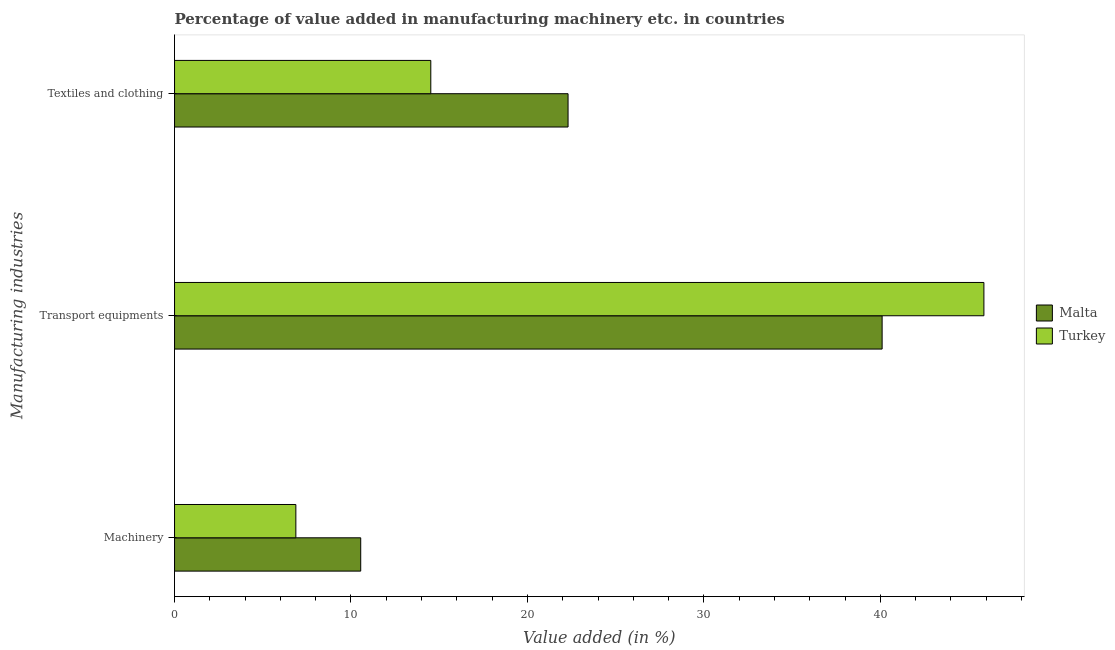Are the number of bars on each tick of the Y-axis equal?
Ensure brevity in your answer.  Yes. How many bars are there on the 3rd tick from the bottom?
Your answer should be compact. 2. What is the label of the 3rd group of bars from the top?
Ensure brevity in your answer.  Machinery. What is the value added in manufacturing machinery in Turkey?
Provide a short and direct response. 6.88. Across all countries, what is the maximum value added in manufacturing textile and clothing?
Your answer should be very brief. 22.3. Across all countries, what is the minimum value added in manufacturing textile and clothing?
Keep it short and to the point. 14.52. In which country was the value added in manufacturing textile and clothing maximum?
Provide a short and direct response. Malta. What is the total value added in manufacturing machinery in the graph?
Give a very brief answer. 17.43. What is the difference between the value added in manufacturing textile and clothing in Turkey and that in Malta?
Keep it short and to the point. -7.78. What is the difference between the value added in manufacturing machinery in Malta and the value added in manufacturing textile and clothing in Turkey?
Your answer should be compact. -3.97. What is the average value added in manufacturing machinery per country?
Provide a succinct answer. 8.71. What is the difference between the value added in manufacturing transport equipments and value added in manufacturing textile and clothing in Malta?
Make the answer very short. 17.8. In how many countries, is the value added in manufacturing transport equipments greater than 20 %?
Keep it short and to the point. 2. What is the ratio of the value added in manufacturing machinery in Turkey to that in Malta?
Make the answer very short. 0.65. Is the value added in manufacturing textile and clothing in Turkey less than that in Malta?
Your response must be concise. Yes. What is the difference between the highest and the second highest value added in manufacturing machinery?
Provide a succinct answer. 3.68. What is the difference between the highest and the lowest value added in manufacturing machinery?
Your answer should be compact. 3.68. In how many countries, is the value added in manufacturing transport equipments greater than the average value added in manufacturing transport equipments taken over all countries?
Give a very brief answer. 1. Is the sum of the value added in manufacturing textile and clothing in Turkey and Malta greater than the maximum value added in manufacturing transport equipments across all countries?
Provide a succinct answer. No. What does the 1st bar from the bottom in Textiles and clothing represents?
Make the answer very short. Malta. Is it the case that in every country, the sum of the value added in manufacturing machinery and value added in manufacturing transport equipments is greater than the value added in manufacturing textile and clothing?
Your answer should be compact. Yes. How many bars are there?
Ensure brevity in your answer.  6. Are all the bars in the graph horizontal?
Make the answer very short. Yes. How many countries are there in the graph?
Keep it short and to the point. 2. What is the difference between two consecutive major ticks on the X-axis?
Your response must be concise. 10. Does the graph contain any zero values?
Offer a very short reply. No. Does the graph contain grids?
Give a very brief answer. No. How are the legend labels stacked?
Your response must be concise. Vertical. What is the title of the graph?
Offer a very short reply. Percentage of value added in manufacturing machinery etc. in countries. What is the label or title of the X-axis?
Give a very brief answer. Value added (in %). What is the label or title of the Y-axis?
Your response must be concise. Manufacturing industries. What is the Value added (in %) of Malta in Machinery?
Offer a terse response. 10.55. What is the Value added (in %) in Turkey in Machinery?
Ensure brevity in your answer.  6.88. What is the Value added (in %) of Malta in Transport equipments?
Provide a short and direct response. 40.1. What is the Value added (in %) in Turkey in Transport equipments?
Offer a very short reply. 45.87. What is the Value added (in %) in Malta in Textiles and clothing?
Your answer should be compact. 22.3. What is the Value added (in %) of Turkey in Textiles and clothing?
Your answer should be compact. 14.52. Across all Manufacturing industries, what is the maximum Value added (in %) of Malta?
Keep it short and to the point. 40.1. Across all Manufacturing industries, what is the maximum Value added (in %) in Turkey?
Your response must be concise. 45.87. Across all Manufacturing industries, what is the minimum Value added (in %) of Malta?
Give a very brief answer. 10.55. Across all Manufacturing industries, what is the minimum Value added (in %) of Turkey?
Provide a succinct answer. 6.88. What is the total Value added (in %) in Malta in the graph?
Offer a very short reply. 72.96. What is the total Value added (in %) of Turkey in the graph?
Give a very brief answer. 67.27. What is the difference between the Value added (in %) in Malta in Machinery and that in Transport equipments?
Your answer should be compact. -29.55. What is the difference between the Value added (in %) in Turkey in Machinery and that in Transport equipments?
Give a very brief answer. -39. What is the difference between the Value added (in %) of Malta in Machinery and that in Textiles and clothing?
Provide a short and direct response. -11.75. What is the difference between the Value added (in %) in Turkey in Machinery and that in Textiles and clothing?
Offer a terse response. -7.65. What is the difference between the Value added (in %) in Malta in Transport equipments and that in Textiles and clothing?
Provide a succinct answer. 17.8. What is the difference between the Value added (in %) in Turkey in Transport equipments and that in Textiles and clothing?
Give a very brief answer. 31.35. What is the difference between the Value added (in %) in Malta in Machinery and the Value added (in %) in Turkey in Transport equipments?
Give a very brief answer. -35.32. What is the difference between the Value added (in %) of Malta in Machinery and the Value added (in %) of Turkey in Textiles and clothing?
Ensure brevity in your answer.  -3.97. What is the difference between the Value added (in %) of Malta in Transport equipments and the Value added (in %) of Turkey in Textiles and clothing?
Provide a short and direct response. 25.58. What is the average Value added (in %) of Malta per Manufacturing industries?
Give a very brief answer. 24.32. What is the average Value added (in %) of Turkey per Manufacturing industries?
Offer a very short reply. 22.42. What is the difference between the Value added (in %) of Malta and Value added (in %) of Turkey in Machinery?
Offer a very short reply. 3.68. What is the difference between the Value added (in %) of Malta and Value added (in %) of Turkey in Transport equipments?
Keep it short and to the point. -5.77. What is the difference between the Value added (in %) in Malta and Value added (in %) in Turkey in Textiles and clothing?
Provide a succinct answer. 7.78. What is the ratio of the Value added (in %) in Malta in Machinery to that in Transport equipments?
Offer a very short reply. 0.26. What is the ratio of the Value added (in %) in Turkey in Machinery to that in Transport equipments?
Your answer should be compact. 0.15. What is the ratio of the Value added (in %) in Malta in Machinery to that in Textiles and clothing?
Provide a short and direct response. 0.47. What is the ratio of the Value added (in %) of Turkey in Machinery to that in Textiles and clothing?
Provide a short and direct response. 0.47. What is the ratio of the Value added (in %) in Malta in Transport equipments to that in Textiles and clothing?
Keep it short and to the point. 1.8. What is the ratio of the Value added (in %) in Turkey in Transport equipments to that in Textiles and clothing?
Give a very brief answer. 3.16. What is the difference between the highest and the second highest Value added (in %) of Malta?
Your answer should be very brief. 17.8. What is the difference between the highest and the second highest Value added (in %) of Turkey?
Give a very brief answer. 31.35. What is the difference between the highest and the lowest Value added (in %) in Malta?
Your answer should be compact. 29.55. What is the difference between the highest and the lowest Value added (in %) of Turkey?
Offer a terse response. 39. 